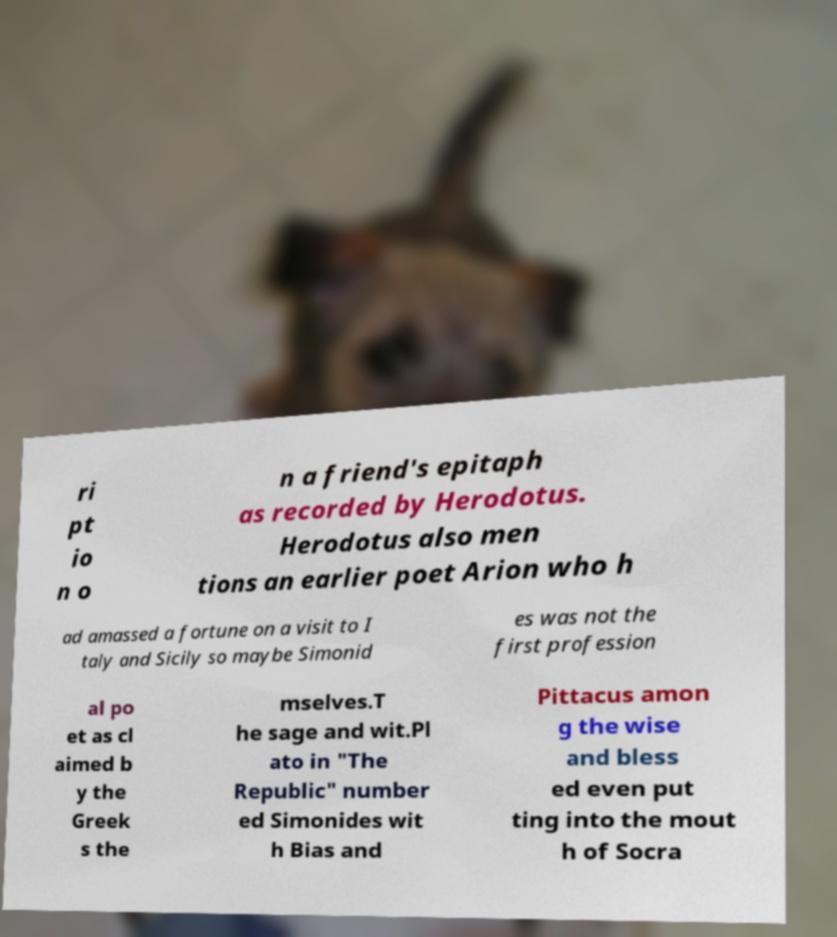Please identify and transcribe the text found in this image. ri pt io n o n a friend's epitaph as recorded by Herodotus. Herodotus also men tions an earlier poet Arion who h ad amassed a fortune on a visit to I taly and Sicily so maybe Simonid es was not the first profession al po et as cl aimed b y the Greek s the mselves.T he sage and wit.Pl ato in "The Republic" number ed Simonides wit h Bias and Pittacus amon g the wise and bless ed even put ting into the mout h of Socra 